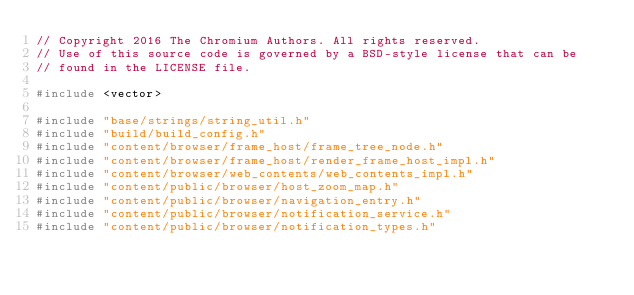Convert code to text. <code><loc_0><loc_0><loc_500><loc_500><_C++_>// Copyright 2016 The Chromium Authors. All rights reserved.
// Use of this source code is governed by a BSD-style license that can be
// found in the LICENSE file.

#include <vector>

#include "base/strings/string_util.h"
#include "build/build_config.h"
#include "content/browser/frame_host/frame_tree_node.h"
#include "content/browser/frame_host/render_frame_host_impl.h"
#include "content/browser/web_contents/web_contents_impl.h"
#include "content/public/browser/host_zoom_map.h"
#include "content/public/browser/navigation_entry.h"
#include "content/public/browser/notification_service.h"
#include "content/public/browser/notification_types.h"</code> 